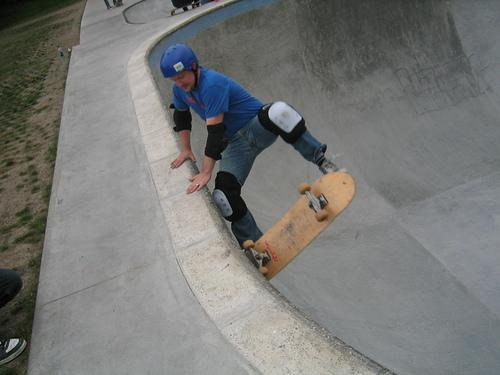What is the area the man is skating in usually called? bowl 